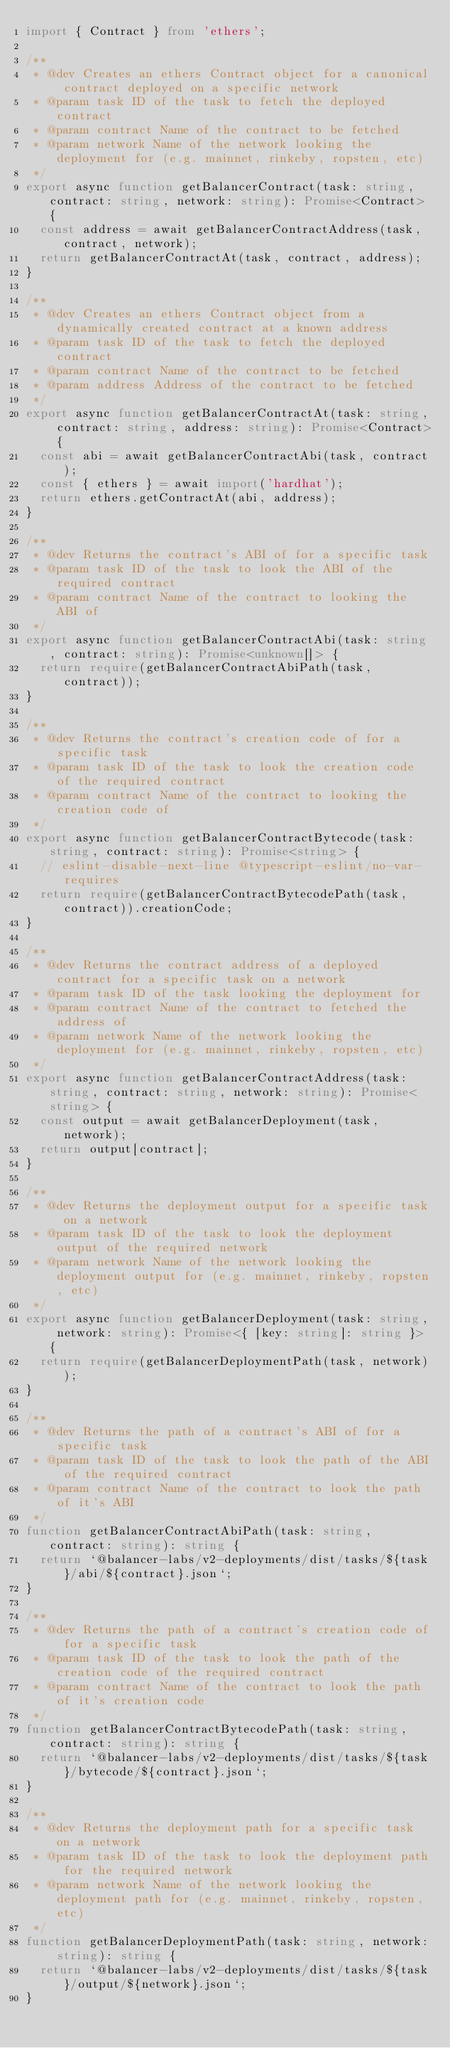Convert code to text. <code><loc_0><loc_0><loc_500><loc_500><_TypeScript_>import { Contract } from 'ethers';

/**
 * @dev Creates an ethers Contract object for a canonical contract deployed on a specific network
 * @param task ID of the task to fetch the deployed contract
 * @param contract Name of the contract to be fetched
 * @param network Name of the network looking the deployment for (e.g. mainnet, rinkeby, ropsten, etc)
 */
export async function getBalancerContract(task: string, contract: string, network: string): Promise<Contract> {
  const address = await getBalancerContractAddress(task, contract, network);
  return getBalancerContractAt(task, contract, address);
}

/**
 * @dev Creates an ethers Contract object from a dynamically created contract at a known address
 * @param task ID of the task to fetch the deployed contract
 * @param contract Name of the contract to be fetched
 * @param address Address of the contract to be fetched
 */
export async function getBalancerContractAt(task: string, contract: string, address: string): Promise<Contract> {
  const abi = await getBalancerContractAbi(task, contract);
  const { ethers } = await import('hardhat');
  return ethers.getContractAt(abi, address);
}

/**
 * @dev Returns the contract's ABI of for a specific task
 * @param task ID of the task to look the ABI of the required contract
 * @param contract Name of the contract to looking the ABI of
 */
export async function getBalancerContractAbi(task: string, contract: string): Promise<unknown[]> {
  return require(getBalancerContractAbiPath(task, contract));
}

/**
 * @dev Returns the contract's creation code of for a specific task
 * @param task ID of the task to look the creation code of the required contract
 * @param contract Name of the contract to looking the creation code of
 */
export async function getBalancerContractBytecode(task: string, contract: string): Promise<string> {
  // eslint-disable-next-line @typescript-eslint/no-var-requires
  return require(getBalancerContractBytecodePath(task, contract)).creationCode;
}

/**
 * @dev Returns the contract address of a deployed contract for a specific task on a network
 * @param task ID of the task looking the deployment for
 * @param contract Name of the contract to fetched the address of
 * @param network Name of the network looking the deployment for (e.g. mainnet, rinkeby, ropsten, etc)
 */
export async function getBalancerContractAddress(task: string, contract: string, network: string): Promise<string> {
  const output = await getBalancerDeployment(task, network);
  return output[contract];
}

/**
 * @dev Returns the deployment output for a specific task on a network
 * @param task ID of the task to look the deployment output of the required network
 * @param network Name of the network looking the deployment output for (e.g. mainnet, rinkeby, ropsten, etc)
 */
export async function getBalancerDeployment(task: string, network: string): Promise<{ [key: string]: string }> {
  return require(getBalancerDeploymentPath(task, network));
}

/**
 * @dev Returns the path of a contract's ABI of for a specific task
 * @param task ID of the task to look the path of the ABI of the required contract
 * @param contract Name of the contract to look the path of it's ABI
 */
function getBalancerContractAbiPath(task: string, contract: string): string {
  return `@balancer-labs/v2-deployments/dist/tasks/${task}/abi/${contract}.json`;
}

/**
 * @dev Returns the path of a contract's creation code of for a specific task
 * @param task ID of the task to look the path of the creation code of the required contract
 * @param contract Name of the contract to look the path of it's creation code
 */
function getBalancerContractBytecodePath(task: string, contract: string): string {
  return `@balancer-labs/v2-deployments/dist/tasks/${task}/bytecode/${contract}.json`;
}

/**
 * @dev Returns the deployment path for a specific task on a network
 * @param task ID of the task to look the deployment path for the required network
 * @param network Name of the network looking the deployment path for (e.g. mainnet, rinkeby, ropsten, etc)
 */
function getBalancerDeploymentPath(task: string, network: string): string {
  return `@balancer-labs/v2-deployments/dist/tasks/${task}/output/${network}.json`;
}
</code> 